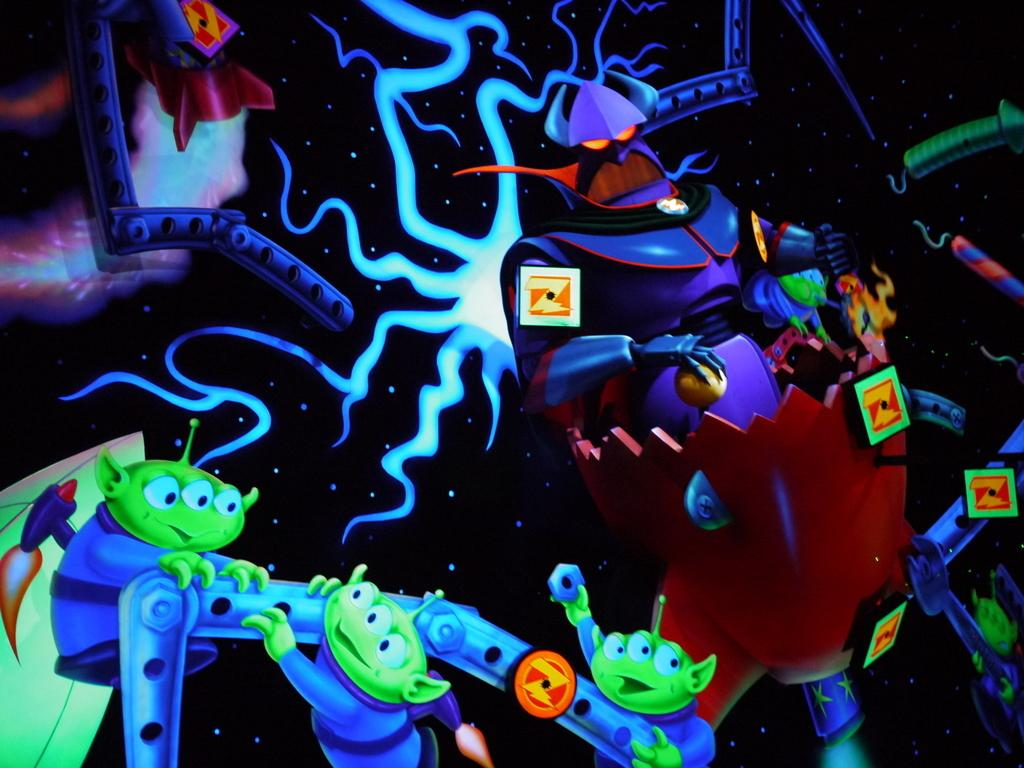What type of images are present in the image? The image contains animation images. What type of account is being discussed in the image? There is no account being discussed in the image, as it only contains animation images. 